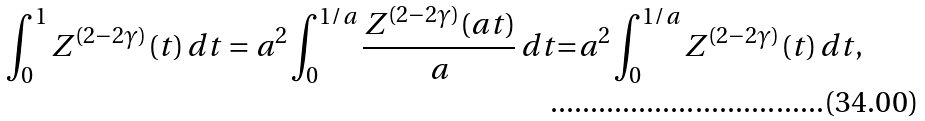Convert formula to latex. <formula><loc_0><loc_0><loc_500><loc_500>\int _ { 0 } ^ { 1 } Z ^ { ( 2 - 2 \gamma ) } ( t ) \, d t = a ^ { 2 } \int _ { 0 } ^ { 1 / a } \frac { Z ^ { ( 2 - 2 \gamma ) } ( a t ) } { a } \, d t { = } a ^ { 2 } \int _ { 0 } ^ { 1 / a } Z ^ { ( 2 - 2 \gamma ) } ( t ) \, d t ,</formula> 